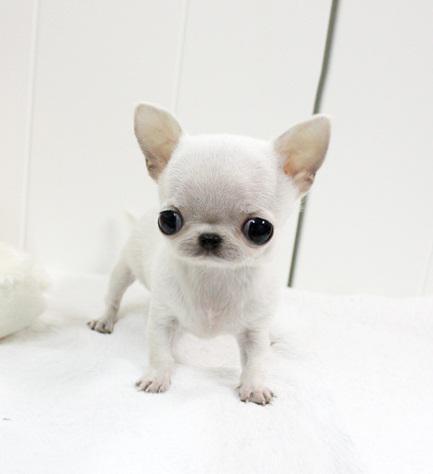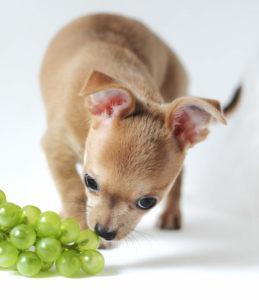The first image is the image on the left, the second image is the image on the right. Evaluate the accuracy of this statement regarding the images: "One dog is eating strawberries.". Is it true? Answer yes or no. No. The first image is the image on the left, the second image is the image on the right. Examine the images to the left and right. Is the description "There is a dog standing beside a white plate full of food on a patterned table in one of the images." accurate? Answer yes or no. No. 